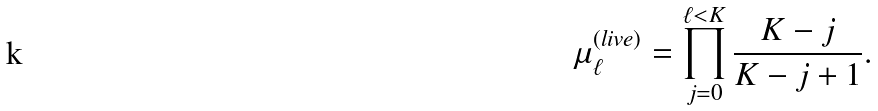Convert formula to latex. <formula><loc_0><loc_0><loc_500><loc_500>\mu _ { \ell } ^ { ( l i v e ) } = \prod _ { j = 0 } ^ { \ell < K } \frac { K - j } { K - j + 1 } .</formula> 